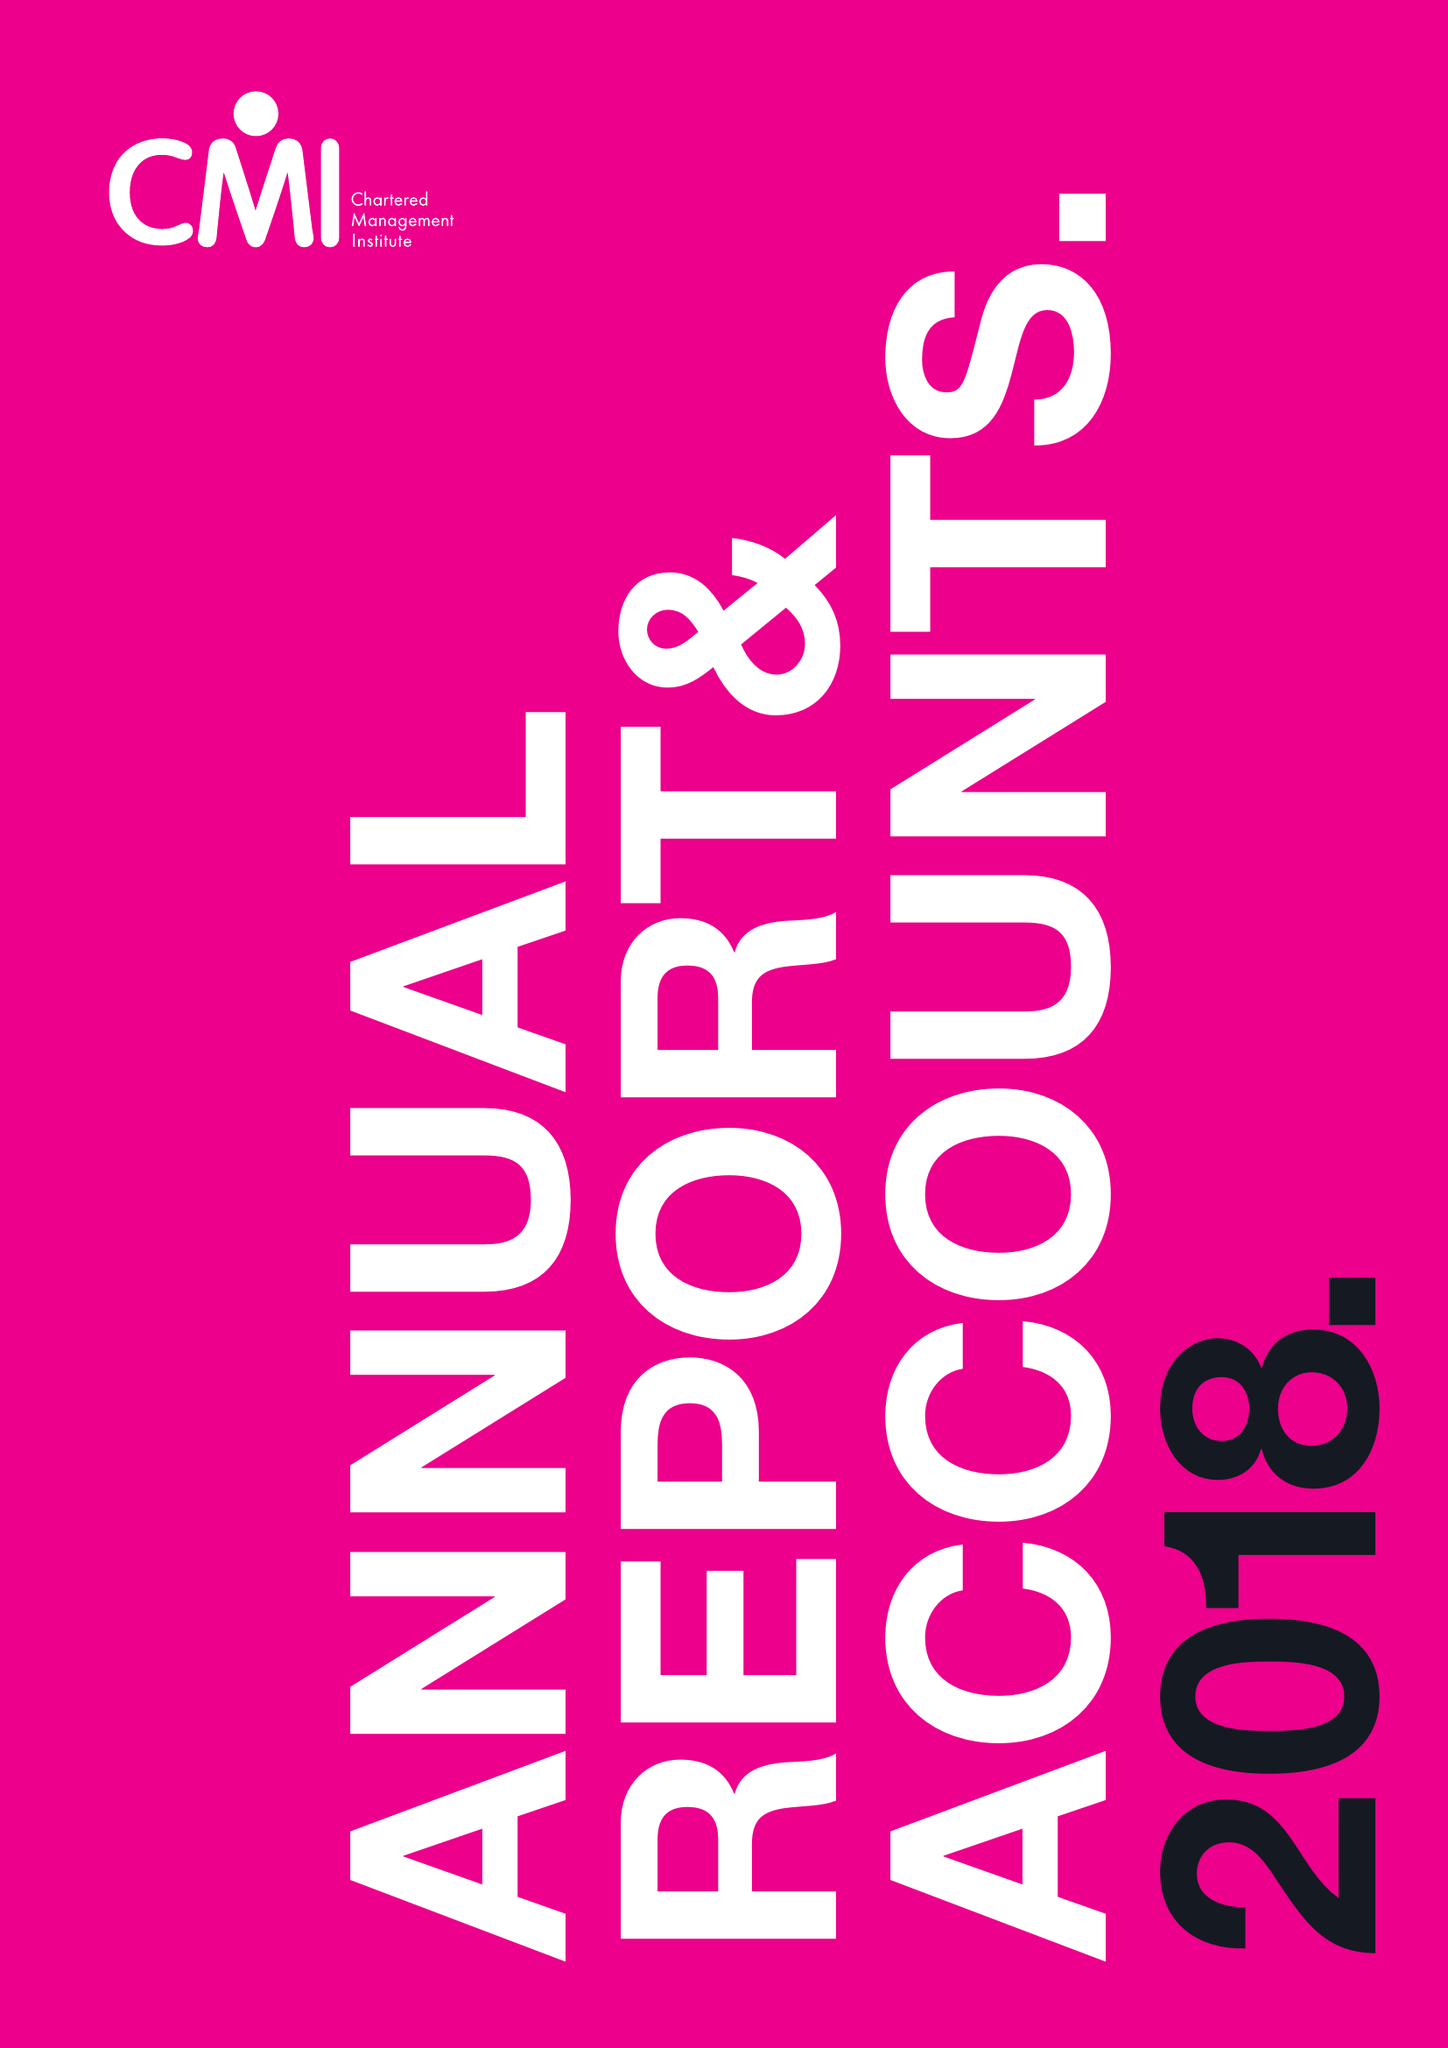What is the value for the report_date?
Answer the question using a single word or phrase. 2018-03-31 